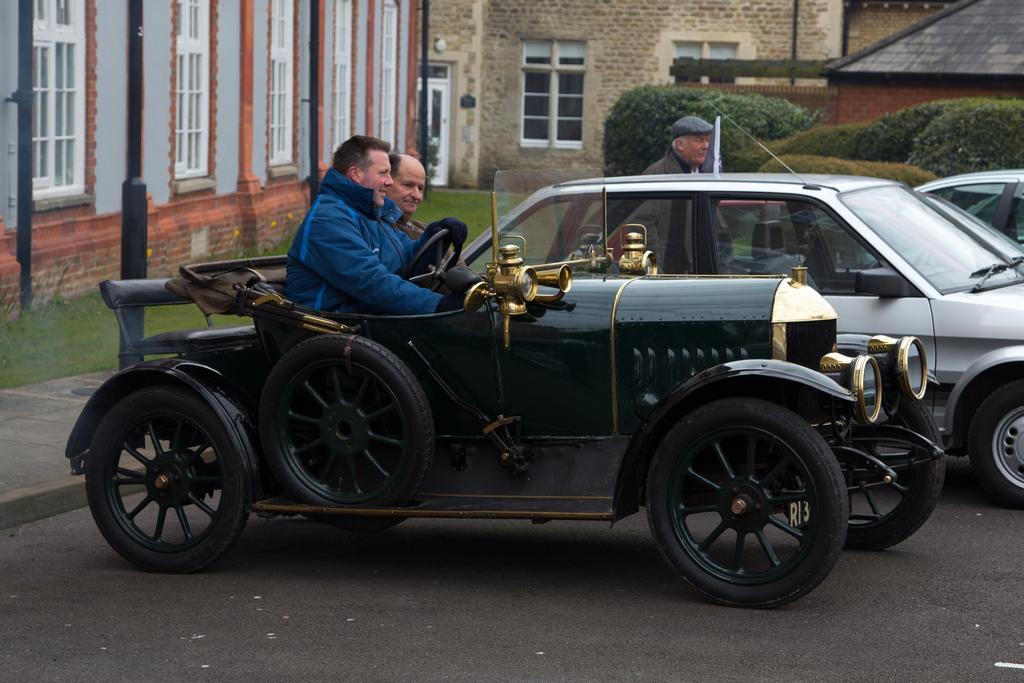In one or two sentences, can you explain what this image depicts? There is a jeep. On that two persons are sitting. Also there are cars. In the back there are buildings with windows. On the ground there is grass. Also there are bushes. 